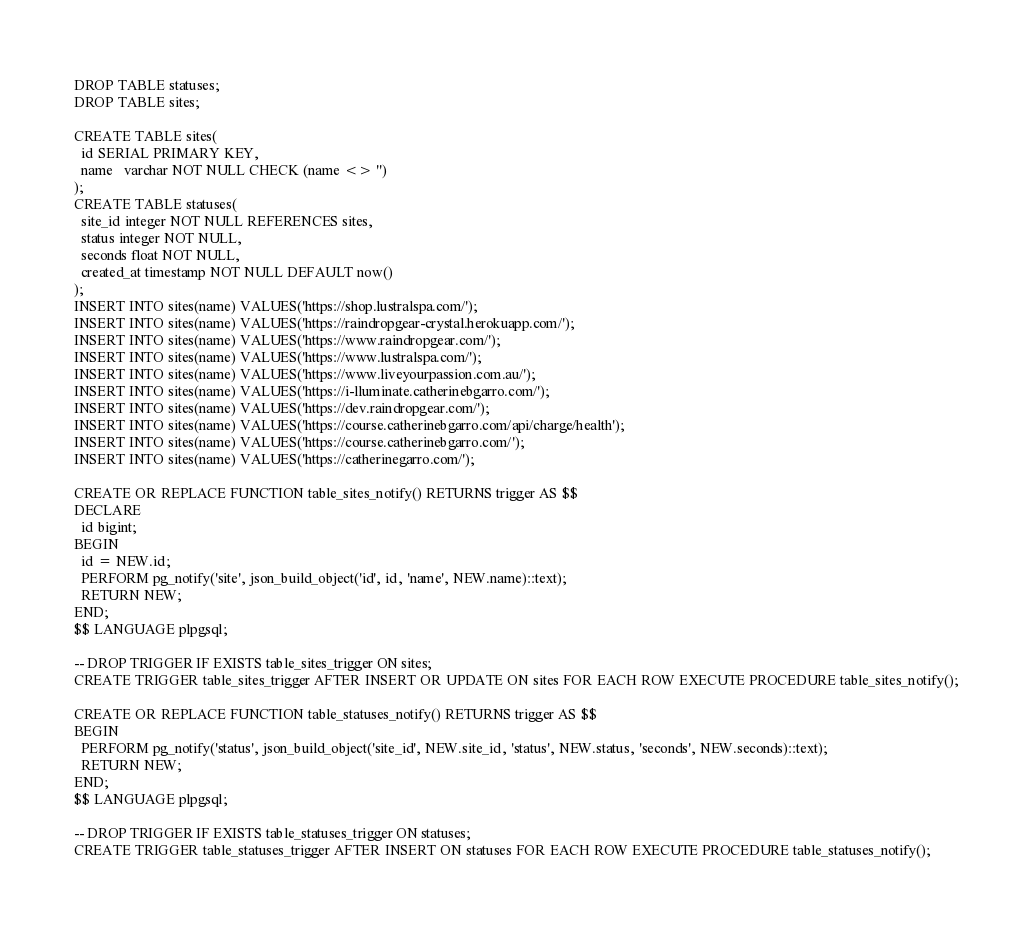<code> <loc_0><loc_0><loc_500><loc_500><_SQL_>DROP TABLE statuses;
DROP TABLE sites;

CREATE TABLE sites(
  id SERIAL PRIMARY KEY,
  name   varchar NOT NULL CHECK (name <> '')
);
CREATE TABLE statuses(
  site_id integer NOT NULL REFERENCES sites,
  status integer NOT NULL,
  seconds float NOT NULL,
  created_at timestamp NOT NULL DEFAULT now()
);
INSERT INTO sites(name) VALUES('https://shop.lustralspa.com/');
INSERT INTO sites(name) VALUES('https://raindropgear-crystal.herokuapp.com/');
INSERT INTO sites(name) VALUES('https://www.raindropgear.com/');
INSERT INTO sites(name) VALUES('https://www.lustralspa.com/');
INSERT INTO sites(name) VALUES('https://www.liveyourpassion.com.au/');
INSERT INTO sites(name) VALUES('https://i-lluminate.catherinebgarro.com/');
INSERT INTO sites(name) VALUES('https://dev.raindropgear.com/');
INSERT INTO sites(name) VALUES('https://course.catherinebgarro.com/api/charge/health');
INSERT INTO sites(name) VALUES('https://course.catherinebgarro.com/');
INSERT INTO sites(name) VALUES('https://catherinegarro.com/');

CREATE OR REPLACE FUNCTION table_sites_notify() RETURNS trigger AS $$
DECLARE
  id bigint;
BEGIN
  id = NEW.id;
  PERFORM pg_notify('site', json_build_object('id', id, 'name', NEW.name)::text);
  RETURN NEW;
END;
$$ LANGUAGE plpgsql;

-- DROP TRIGGER IF EXISTS table_sites_trigger ON sites;
CREATE TRIGGER table_sites_trigger AFTER INSERT OR UPDATE ON sites FOR EACH ROW EXECUTE PROCEDURE table_sites_notify();

CREATE OR REPLACE FUNCTION table_statuses_notify() RETURNS trigger AS $$
BEGIN
  PERFORM pg_notify('status', json_build_object('site_id', NEW.site_id, 'status', NEW.status, 'seconds', NEW.seconds)::text);
  RETURN NEW;
END;
$$ LANGUAGE plpgsql;

-- DROP TRIGGER IF EXISTS table_statuses_trigger ON statuses;
CREATE TRIGGER table_statuses_trigger AFTER INSERT ON statuses FOR EACH ROW EXECUTE PROCEDURE table_statuses_notify();
</code> 